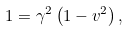Convert formula to latex. <formula><loc_0><loc_0><loc_500><loc_500>1 = \gamma ^ { 2 } \left ( 1 - v ^ { 2 } \right ) ,</formula> 